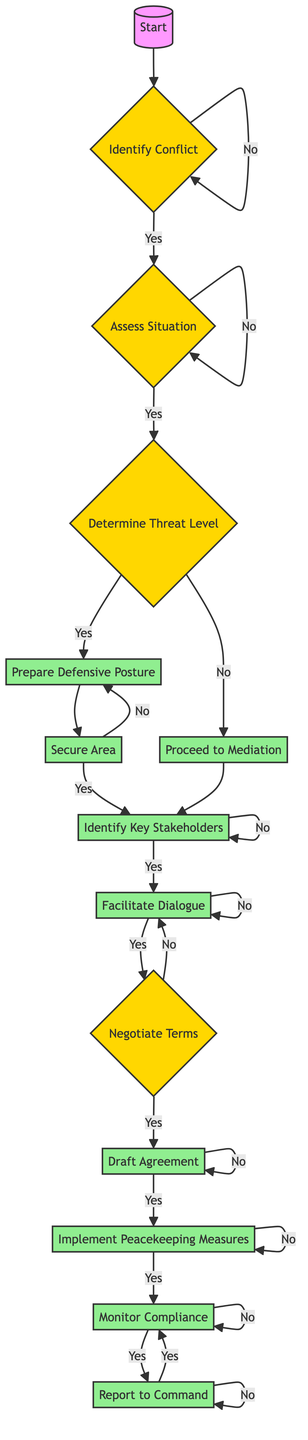What is the first step in the conflict resolution process? The first step is to identify the conflict, as indicated by the 'Start' node leading to 'Identify Conflict'.
Answer: Identify Conflict What follows after 'Assess Situation' if the answer is 'Yes'? If the answer is 'Yes' to 'Assess Situation', the next step is 'Determine Threat Level', which is the direct connection from 'Assess Situation' to 'Determine Threat Level'.
Answer: Determine Threat Level How many nodes represent actions in the diagram? The action nodes in the diagram are 'Prepare Defensive Posture', 'Secure Area', 'Proceed to Mediation', 'Identify Key Stakeholders', 'Facilitate Dialogue', 'Negotiate Terms', 'Draft Agreement', 'Implement Peacekeeping Measures', 'Monitor Compliance', and 'Report to Command', totaling 10 action nodes.
Answer: 10 What happens if the threat level is assessed as low? If the threat level is assessed as low ('No' response to 'Is Threat Level High?'), the process proceeds to 'Proceed to Mediation', as indicated by the flow from 'Determine Threat Level'.
Answer: Proceed to Mediation What is the last action taken in the process according to the diagram? The last action taken in the process is to 'Report to Command', as shown by the final flow node connecting to this action after 'Monitor Compliance'.
Answer: Report to Command After 'Prepare Defensive Posture', if the area is secured, which action comes next? After 'Prepare Defensive Posture', if the area is secured ('Yes'), the next action is to 'Establish Security Perimeter', which leads to 'Initiate Negotiations', according to the flow.
Answer: Initiate Negotiations Which node signifies the need to involve UN representatives? The node that signifies the need to involve UN representatives is 'Identify Key Stakeholders', from the flow after either 'Secure Area' or 'Proceed to Mediation'.
Answer: Identify Key Stakeholders If the terms are not accepted during negotiation, what step must be taken? If the terms are not accepted during the negotiations ('No' response to 'Are Terms Accepted?'), the next step is to 'Revise Proposal', as per the decision flow after 'Negotiate Terms'.
Answer: Revise Proposal What do you do after drafting the agreement? After drafting the agreement, the next step is to 'Implement Peacekeeping Measures', based on the direct connection from 'Draft Agreement'.
Answer: Implement Peacekeeping Measures 